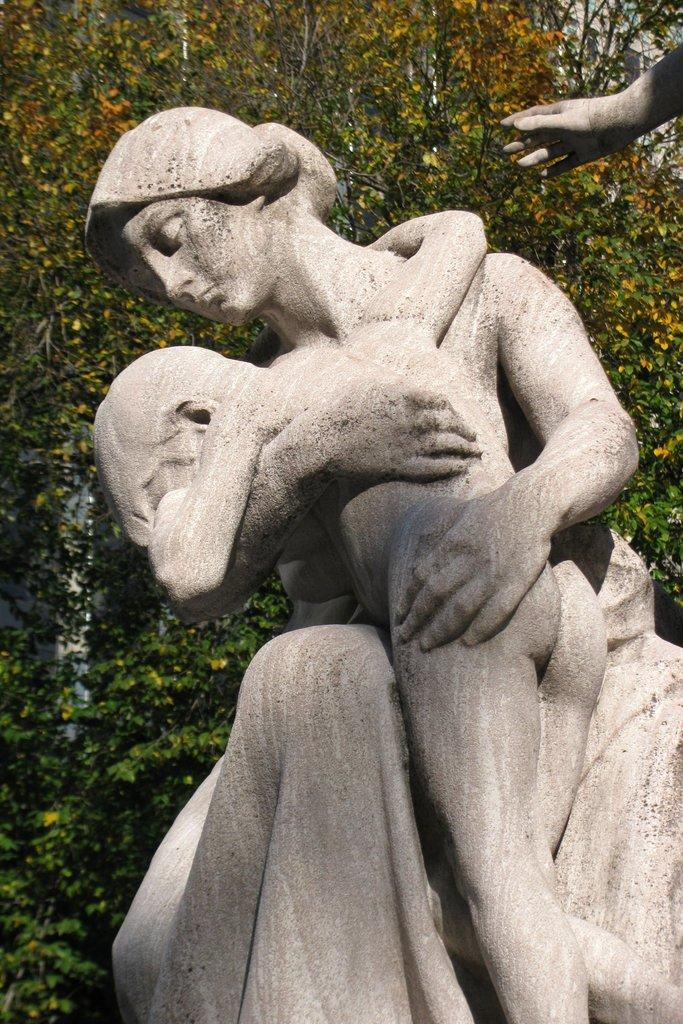What type of objects can be seen in the image? There are statues and creepers in the image. Can you describe the statues in the image? The provided facts do not give specific details about the statues, so we cannot describe them further. What type of vegetation is represented by the creepers in the image? The creepers in the image are likely a type of climbing plant, but the specific species cannot be determined from the provided facts. How many girls are sitting on the statues in the image? There is no mention of girls in the image, so we cannot answer this question. 